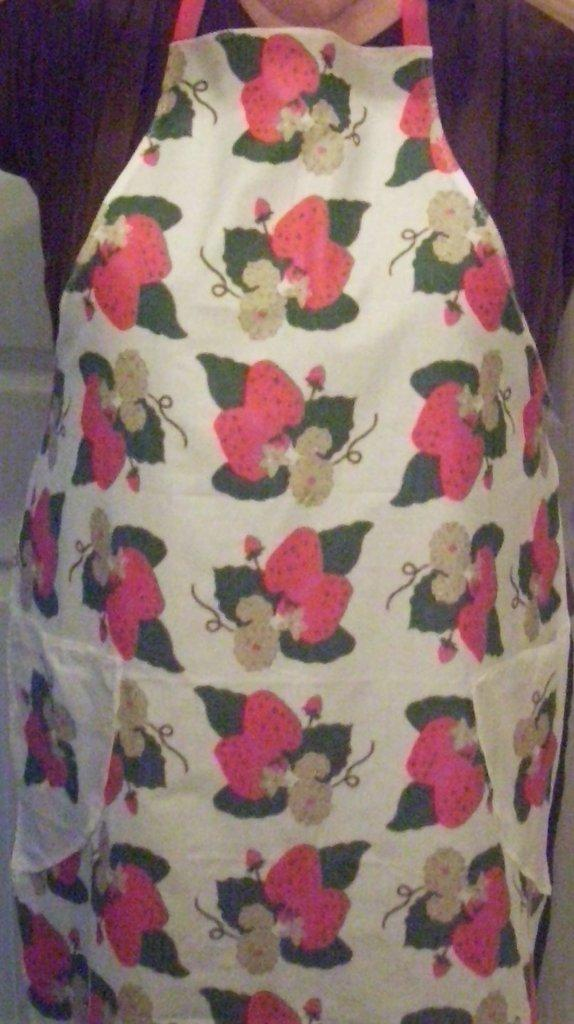What is the main subject of the image? There is a person in the image. What is the person wearing? The person is wearing a kitchen dress. What type of amusement can be seen in the image? There is no amusement present in the image; it features a person wearing a kitchen dress. Can you tell me how many robins are visible in the image? There are no robins present in the image. 